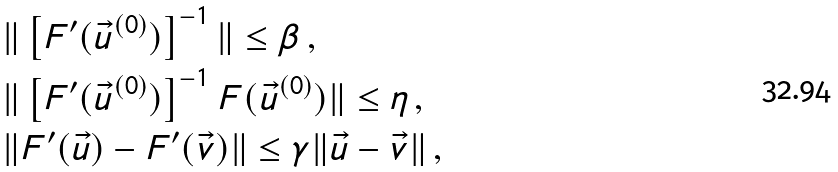<formula> <loc_0><loc_0><loc_500><loc_500>& \| \left [ F ^ { \prime } ( \vec { u } ^ { ( 0 ) } ) \right ] ^ { - 1 } \| \leq \beta \, , \\ & \| \left [ F ^ { \prime } ( \vec { u } ^ { ( 0 ) } ) \right ] ^ { - 1 } F ( \vec { u } ^ { ( 0 ) } ) \| \leq \eta \, , \\ & \| F ^ { \prime } ( \vec { u } ) - F ^ { \prime } ( \vec { v } ) \| \leq \gamma \| \vec { u } - \vec { v } \| \, ,</formula> 